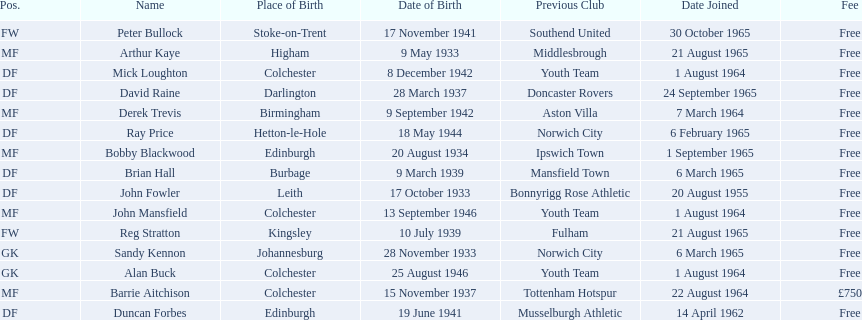When did each player join? 1 August 1964, 6 March 1965, 14 April 1962, 20 August 1955, 6 March 1965, 1 August 1964, 6 February 1965, 24 September 1965, 22 August 1964, 1 September 1965, 21 August 1965, 1 August 1964, 7 March 1964, 30 October 1965, 21 August 1965. And of those, which is the earliest join date? 20 August 1955. 